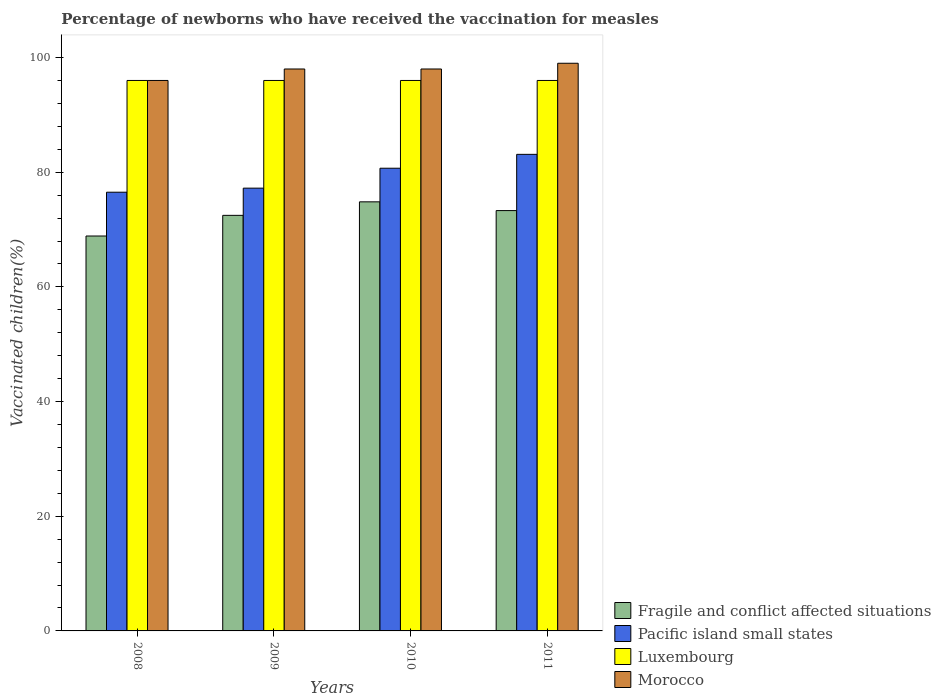How many groups of bars are there?
Your answer should be very brief. 4. How many bars are there on the 3rd tick from the left?
Offer a terse response. 4. What is the label of the 2nd group of bars from the left?
Your response must be concise. 2009. In how many cases, is the number of bars for a given year not equal to the number of legend labels?
Give a very brief answer. 0. What is the percentage of vaccinated children in Pacific island small states in 2011?
Your response must be concise. 83.11. Across all years, what is the maximum percentage of vaccinated children in Morocco?
Provide a succinct answer. 99. Across all years, what is the minimum percentage of vaccinated children in Pacific island small states?
Provide a short and direct response. 76.51. What is the total percentage of vaccinated children in Pacific island small states in the graph?
Ensure brevity in your answer.  317.53. What is the difference between the percentage of vaccinated children in Fragile and conflict affected situations in 2009 and that in 2010?
Your answer should be compact. -2.36. What is the difference between the percentage of vaccinated children in Fragile and conflict affected situations in 2008 and the percentage of vaccinated children in Luxembourg in 2011?
Give a very brief answer. -27.13. What is the average percentage of vaccinated children in Morocco per year?
Give a very brief answer. 97.75. In the year 2011, what is the difference between the percentage of vaccinated children in Pacific island small states and percentage of vaccinated children in Luxembourg?
Offer a terse response. -12.89. In how many years, is the percentage of vaccinated children in Pacific island small states greater than 12 %?
Offer a very short reply. 4. What is the ratio of the percentage of vaccinated children in Fragile and conflict affected situations in 2008 to that in 2009?
Provide a short and direct response. 0.95. Is the difference between the percentage of vaccinated children in Pacific island small states in 2009 and 2010 greater than the difference between the percentage of vaccinated children in Luxembourg in 2009 and 2010?
Offer a very short reply. No. What is the difference between the highest and the second highest percentage of vaccinated children in Pacific island small states?
Provide a short and direct response. 2.42. What is the difference between the highest and the lowest percentage of vaccinated children in Pacific island small states?
Offer a terse response. 6.6. In how many years, is the percentage of vaccinated children in Luxembourg greater than the average percentage of vaccinated children in Luxembourg taken over all years?
Ensure brevity in your answer.  0. What does the 1st bar from the left in 2010 represents?
Ensure brevity in your answer.  Fragile and conflict affected situations. What does the 4th bar from the right in 2011 represents?
Your answer should be very brief. Fragile and conflict affected situations. How many bars are there?
Offer a terse response. 16. How many years are there in the graph?
Keep it short and to the point. 4. Does the graph contain any zero values?
Make the answer very short. No. Where does the legend appear in the graph?
Provide a succinct answer. Bottom right. How are the legend labels stacked?
Keep it short and to the point. Vertical. What is the title of the graph?
Give a very brief answer. Percentage of newborns who have received the vaccination for measles. Does "Paraguay" appear as one of the legend labels in the graph?
Give a very brief answer. No. What is the label or title of the Y-axis?
Your answer should be very brief. Vaccinated children(%). What is the Vaccinated children(%) in Fragile and conflict affected situations in 2008?
Keep it short and to the point. 68.87. What is the Vaccinated children(%) of Pacific island small states in 2008?
Give a very brief answer. 76.51. What is the Vaccinated children(%) in Luxembourg in 2008?
Offer a terse response. 96. What is the Vaccinated children(%) of Morocco in 2008?
Ensure brevity in your answer.  96. What is the Vaccinated children(%) of Fragile and conflict affected situations in 2009?
Make the answer very short. 72.47. What is the Vaccinated children(%) of Pacific island small states in 2009?
Provide a short and direct response. 77.22. What is the Vaccinated children(%) in Luxembourg in 2009?
Ensure brevity in your answer.  96. What is the Vaccinated children(%) of Morocco in 2009?
Provide a succinct answer. 98. What is the Vaccinated children(%) in Fragile and conflict affected situations in 2010?
Your answer should be very brief. 74.83. What is the Vaccinated children(%) of Pacific island small states in 2010?
Your answer should be very brief. 80.69. What is the Vaccinated children(%) of Luxembourg in 2010?
Keep it short and to the point. 96. What is the Vaccinated children(%) of Fragile and conflict affected situations in 2011?
Offer a terse response. 73.31. What is the Vaccinated children(%) of Pacific island small states in 2011?
Keep it short and to the point. 83.11. What is the Vaccinated children(%) in Luxembourg in 2011?
Your answer should be very brief. 96. What is the Vaccinated children(%) of Morocco in 2011?
Your answer should be compact. 99. Across all years, what is the maximum Vaccinated children(%) of Fragile and conflict affected situations?
Offer a terse response. 74.83. Across all years, what is the maximum Vaccinated children(%) of Pacific island small states?
Make the answer very short. 83.11. Across all years, what is the maximum Vaccinated children(%) in Luxembourg?
Offer a very short reply. 96. Across all years, what is the minimum Vaccinated children(%) in Fragile and conflict affected situations?
Ensure brevity in your answer.  68.87. Across all years, what is the minimum Vaccinated children(%) of Pacific island small states?
Your answer should be compact. 76.51. Across all years, what is the minimum Vaccinated children(%) in Luxembourg?
Make the answer very short. 96. Across all years, what is the minimum Vaccinated children(%) of Morocco?
Your answer should be compact. 96. What is the total Vaccinated children(%) of Fragile and conflict affected situations in the graph?
Give a very brief answer. 289.49. What is the total Vaccinated children(%) of Pacific island small states in the graph?
Your answer should be compact. 317.53. What is the total Vaccinated children(%) of Luxembourg in the graph?
Give a very brief answer. 384. What is the total Vaccinated children(%) of Morocco in the graph?
Your response must be concise. 391. What is the difference between the Vaccinated children(%) in Fragile and conflict affected situations in 2008 and that in 2009?
Offer a very short reply. -3.6. What is the difference between the Vaccinated children(%) in Pacific island small states in 2008 and that in 2009?
Give a very brief answer. -0.71. What is the difference between the Vaccinated children(%) of Luxembourg in 2008 and that in 2009?
Offer a terse response. 0. What is the difference between the Vaccinated children(%) in Morocco in 2008 and that in 2009?
Offer a very short reply. -2. What is the difference between the Vaccinated children(%) of Fragile and conflict affected situations in 2008 and that in 2010?
Your answer should be very brief. -5.96. What is the difference between the Vaccinated children(%) of Pacific island small states in 2008 and that in 2010?
Offer a very short reply. -4.18. What is the difference between the Vaccinated children(%) of Fragile and conflict affected situations in 2008 and that in 2011?
Offer a very short reply. -4.43. What is the difference between the Vaccinated children(%) in Pacific island small states in 2008 and that in 2011?
Your answer should be compact. -6.6. What is the difference between the Vaccinated children(%) of Luxembourg in 2008 and that in 2011?
Offer a very short reply. 0. What is the difference between the Vaccinated children(%) of Morocco in 2008 and that in 2011?
Ensure brevity in your answer.  -3. What is the difference between the Vaccinated children(%) of Fragile and conflict affected situations in 2009 and that in 2010?
Your answer should be very brief. -2.36. What is the difference between the Vaccinated children(%) of Pacific island small states in 2009 and that in 2010?
Offer a very short reply. -3.47. What is the difference between the Vaccinated children(%) in Fragile and conflict affected situations in 2009 and that in 2011?
Keep it short and to the point. -0.83. What is the difference between the Vaccinated children(%) in Pacific island small states in 2009 and that in 2011?
Give a very brief answer. -5.89. What is the difference between the Vaccinated children(%) of Luxembourg in 2009 and that in 2011?
Your answer should be very brief. 0. What is the difference between the Vaccinated children(%) in Fragile and conflict affected situations in 2010 and that in 2011?
Provide a short and direct response. 1.53. What is the difference between the Vaccinated children(%) in Pacific island small states in 2010 and that in 2011?
Offer a very short reply. -2.42. What is the difference between the Vaccinated children(%) in Luxembourg in 2010 and that in 2011?
Provide a succinct answer. 0. What is the difference between the Vaccinated children(%) of Morocco in 2010 and that in 2011?
Provide a short and direct response. -1. What is the difference between the Vaccinated children(%) in Fragile and conflict affected situations in 2008 and the Vaccinated children(%) in Pacific island small states in 2009?
Make the answer very short. -8.35. What is the difference between the Vaccinated children(%) of Fragile and conflict affected situations in 2008 and the Vaccinated children(%) of Luxembourg in 2009?
Give a very brief answer. -27.13. What is the difference between the Vaccinated children(%) in Fragile and conflict affected situations in 2008 and the Vaccinated children(%) in Morocco in 2009?
Ensure brevity in your answer.  -29.13. What is the difference between the Vaccinated children(%) in Pacific island small states in 2008 and the Vaccinated children(%) in Luxembourg in 2009?
Your response must be concise. -19.49. What is the difference between the Vaccinated children(%) in Pacific island small states in 2008 and the Vaccinated children(%) in Morocco in 2009?
Your response must be concise. -21.49. What is the difference between the Vaccinated children(%) in Luxembourg in 2008 and the Vaccinated children(%) in Morocco in 2009?
Ensure brevity in your answer.  -2. What is the difference between the Vaccinated children(%) in Fragile and conflict affected situations in 2008 and the Vaccinated children(%) in Pacific island small states in 2010?
Provide a succinct answer. -11.82. What is the difference between the Vaccinated children(%) in Fragile and conflict affected situations in 2008 and the Vaccinated children(%) in Luxembourg in 2010?
Offer a terse response. -27.13. What is the difference between the Vaccinated children(%) in Fragile and conflict affected situations in 2008 and the Vaccinated children(%) in Morocco in 2010?
Your response must be concise. -29.13. What is the difference between the Vaccinated children(%) of Pacific island small states in 2008 and the Vaccinated children(%) of Luxembourg in 2010?
Keep it short and to the point. -19.49. What is the difference between the Vaccinated children(%) in Pacific island small states in 2008 and the Vaccinated children(%) in Morocco in 2010?
Keep it short and to the point. -21.49. What is the difference between the Vaccinated children(%) in Luxembourg in 2008 and the Vaccinated children(%) in Morocco in 2010?
Keep it short and to the point. -2. What is the difference between the Vaccinated children(%) of Fragile and conflict affected situations in 2008 and the Vaccinated children(%) of Pacific island small states in 2011?
Provide a short and direct response. -14.24. What is the difference between the Vaccinated children(%) in Fragile and conflict affected situations in 2008 and the Vaccinated children(%) in Luxembourg in 2011?
Keep it short and to the point. -27.13. What is the difference between the Vaccinated children(%) in Fragile and conflict affected situations in 2008 and the Vaccinated children(%) in Morocco in 2011?
Ensure brevity in your answer.  -30.13. What is the difference between the Vaccinated children(%) of Pacific island small states in 2008 and the Vaccinated children(%) of Luxembourg in 2011?
Keep it short and to the point. -19.49. What is the difference between the Vaccinated children(%) in Pacific island small states in 2008 and the Vaccinated children(%) in Morocco in 2011?
Keep it short and to the point. -22.49. What is the difference between the Vaccinated children(%) of Luxembourg in 2008 and the Vaccinated children(%) of Morocco in 2011?
Your answer should be very brief. -3. What is the difference between the Vaccinated children(%) in Fragile and conflict affected situations in 2009 and the Vaccinated children(%) in Pacific island small states in 2010?
Your answer should be compact. -8.22. What is the difference between the Vaccinated children(%) of Fragile and conflict affected situations in 2009 and the Vaccinated children(%) of Luxembourg in 2010?
Give a very brief answer. -23.53. What is the difference between the Vaccinated children(%) of Fragile and conflict affected situations in 2009 and the Vaccinated children(%) of Morocco in 2010?
Offer a terse response. -25.53. What is the difference between the Vaccinated children(%) of Pacific island small states in 2009 and the Vaccinated children(%) of Luxembourg in 2010?
Your response must be concise. -18.78. What is the difference between the Vaccinated children(%) of Pacific island small states in 2009 and the Vaccinated children(%) of Morocco in 2010?
Keep it short and to the point. -20.78. What is the difference between the Vaccinated children(%) of Fragile and conflict affected situations in 2009 and the Vaccinated children(%) of Pacific island small states in 2011?
Keep it short and to the point. -10.64. What is the difference between the Vaccinated children(%) in Fragile and conflict affected situations in 2009 and the Vaccinated children(%) in Luxembourg in 2011?
Your response must be concise. -23.53. What is the difference between the Vaccinated children(%) of Fragile and conflict affected situations in 2009 and the Vaccinated children(%) of Morocco in 2011?
Provide a succinct answer. -26.53. What is the difference between the Vaccinated children(%) of Pacific island small states in 2009 and the Vaccinated children(%) of Luxembourg in 2011?
Keep it short and to the point. -18.78. What is the difference between the Vaccinated children(%) in Pacific island small states in 2009 and the Vaccinated children(%) in Morocco in 2011?
Your answer should be very brief. -21.78. What is the difference between the Vaccinated children(%) of Fragile and conflict affected situations in 2010 and the Vaccinated children(%) of Pacific island small states in 2011?
Your answer should be compact. -8.28. What is the difference between the Vaccinated children(%) of Fragile and conflict affected situations in 2010 and the Vaccinated children(%) of Luxembourg in 2011?
Keep it short and to the point. -21.17. What is the difference between the Vaccinated children(%) of Fragile and conflict affected situations in 2010 and the Vaccinated children(%) of Morocco in 2011?
Offer a terse response. -24.17. What is the difference between the Vaccinated children(%) of Pacific island small states in 2010 and the Vaccinated children(%) of Luxembourg in 2011?
Your answer should be very brief. -15.31. What is the difference between the Vaccinated children(%) of Pacific island small states in 2010 and the Vaccinated children(%) of Morocco in 2011?
Your answer should be very brief. -18.31. What is the average Vaccinated children(%) of Fragile and conflict affected situations per year?
Make the answer very short. 72.37. What is the average Vaccinated children(%) in Pacific island small states per year?
Your answer should be very brief. 79.38. What is the average Vaccinated children(%) in Luxembourg per year?
Your answer should be compact. 96. What is the average Vaccinated children(%) of Morocco per year?
Your answer should be compact. 97.75. In the year 2008, what is the difference between the Vaccinated children(%) in Fragile and conflict affected situations and Vaccinated children(%) in Pacific island small states?
Offer a terse response. -7.64. In the year 2008, what is the difference between the Vaccinated children(%) of Fragile and conflict affected situations and Vaccinated children(%) of Luxembourg?
Provide a short and direct response. -27.13. In the year 2008, what is the difference between the Vaccinated children(%) in Fragile and conflict affected situations and Vaccinated children(%) in Morocco?
Give a very brief answer. -27.13. In the year 2008, what is the difference between the Vaccinated children(%) in Pacific island small states and Vaccinated children(%) in Luxembourg?
Your response must be concise. -19.49. In the year 2008, what is the difference between the Vaccinated children(%) in Pacific island small states and Vaccinated children(%) in Morocco?
Provide a succinct answer. -19.49. In the year 2009, what is the difference between the Vaccinated children(%) of Fragile and conflict affected situations and Vaccinated children(%) of Pacific island small states?
Offer a terse response. -4.75. In the year 2009, what is the difference between the Vaccinated children(%) in Fragile and conflict affected situations and Vaccinated children(%) in Luxembourg?
Give a very brief answer. -23.53. In the year 2009, what is the difference between the Vaccinated children(%) of Fragile and conflict affected situations and Vaccinated children(%) of Morocco?
Give a very brief answer. -25.53. In the year 2009, what is the difference between the Vaccinated children(%) of Pacific island small states and Vaccinated children(%) of Luxembourg?
Offer a very short reply. -18.78. In the year 2009, what is the difference between the Vaccinated children(%) of Pacific island small states and Vaccinated children(%) of Morocco?
Your answer should be compact. -20.78. In the year 2009, what is the difference between the Vaccinated children(%) of Luxembourg and Vaccinated children(%) of Morocco?
Give a very brief answer. -2. In the year 2010, what is the difference between the Vaccinated children(%) of Fragile and conflict affected situations and Vaccinated children(%) of Pacific island small states?
Your answer should be very brief. -5.86. In the year 2010, what is the difference between the Vaccinated children(%) in Fragile and conflict affected situations and Vaccinated children(%) in Luxembourg?
Your answer should be compact. -21.17. In the year 2010, what is the difference between the Vaccinated children(%) of Fragile and conflict affected situations and Vaccinated children(%) of Morocco?
Offer a very short reply. -23.17. In the year 2010, what is the difference between the Vaccinated children(%) of Pacific island small states and Vaccinated children(%) of Luxembourg?
Offer a very short reply. -15.31. In the year 2010, what is the difference between the Vaccinated children(%) of Pacific island small states and Vaccinated children(%) of Morocco?
Provide a succinct answer. -17.31. In the year 2011, what is the difference between the Vaccinated children(%) of Fragile and conflict affected situations and Vaccinated children(%) of Pacific island small states?
Offer a very short reply. -9.8. In the year 2011, what is the difference between the Vaccinated children(%) in Fragile and conflict affected situations and Vaccinated children(%) in Luxembourg?
Keep it short and to the point. -22.69. In the year 2011, what is the difference between the Vaccinated children(%) in Fragile and conflict affected situations and Vaccinated children(%) in Morocco?
Offer a terse response. -25.69. In the year 2011, what is the difference between the Vaccinated children(%) in Pacific island small states and Vaccinated children(%) in Luxembourg?
Offer a very short reply. -12.89. In the year 2011, what is the difference between the Vaccinated children(%) of Pacific island small states and Vaccinated children(%) of Morocco?
Your answer should be very brief. -15.89. In the year 2011, what is the difference between the Vaccinated children(%) of Luxembourg and Vaccinated children(%) of Morocco?
Your response must be concise. -3. What is the ratio of the Vaccinated children(%) in Fragile and conflict affected situations in 2008 to that in 2009?
Offer a terse response. 0.95. What is the ratio of the Vaccinated children(%) of Luxembourg in 2008 to that in 2009?
Ensure brevity in your answer.  1. What is the ratio of the Vaccinated children(%) in Morocco in 2008 to that in 2009?
Provide a succinct answer. 0.98. What is the ratio of the Vaccinated children(%) in Fragile and conflict affected situations in 2008 to that in 2010?
Your response must be concise. 0.92. What is the ratio of the Vaccinated children(%) in Pacific island small states in 2008 to that in 2010?
Offer a very short reply. 0.95. What is the ratio of the Vaccinated children(%) in Morocco in 2008 to that in 2010?
Make the answer very short. 0.98. What is the ratio of the Vaccinated children(%) in Fragile and conflict affected situations in 2008 to that in 2011?
Make the answer very short. 0.94. What is the ratio of the Vaccinated children(%) of Pacific island small states in 2008 to that in 2011?
Your answer should be compact. 0.92. What is the ratio of the Vaccinated children(%) of Morocco in 2008 to that in 2011?
Your answer should be compact. 0.97. What is the ratio of the Vaccinated children(%) of Fragile and conflict affected situations in 2009 to that in 2010?
Provide a short and direct response. 0.97. What is the ratio of the Vaccinated children(%) in Pacific island small states in 2009 to that in 2011?
Your answer should be compact. 0.93. What is the ratio of the Vaccinated children(%) of Fragile and conflict affected situations in 2010 to that in 2011?
Your response must be concise. 1.02. What is the ratio of the Vaccinated children(%) in Pacific island small states in 2010 to that in 2011?
Provide a short and direct response. 0.97. What is the difference between the highest and the second highest Vaccinated children(%) of Fragile and conflict affected situations?
Provide a succinct answer. 1.53. What is the difference between the highest and the second highest Vaccinated children(%) of Pacific island small states?
Offer a terse response. 2.42. What is the difference between the highest and the second highest Vaccinated children(%) in Luxembourg?
Make the answer very short. 0. What is the difference between the highest and the lowest Vaccinated children(%) in Fragile and conflict affected situations?
Keep it short and to the point. 5.96. What is the difference between the highest and the lowest Vaccinated children(%) in Pacific island small states?
Your answer should be very brief. 6.6. What is the difference between the highest and the lowest Vaccinated children(%) of Luxembourg?
Provide a succinct answer. 0. What is the difference between the highest and the lowest Vaccinated children(%) of Morocco?
Offer a very short reply. 3. 